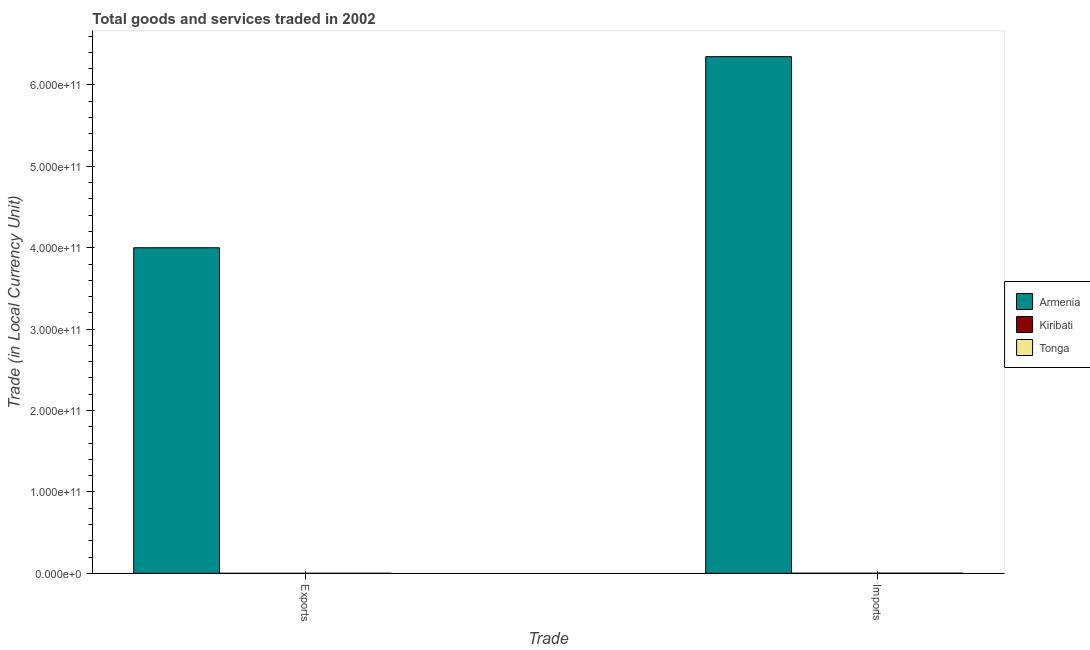How many different coloured bars are there?
Keep it short and to the point. 3. Are the number of bars on each tick of the X-axis equal?
Give a very brief answer. Yes. How many bars are there on the 1st tick from the left?
Your answer should be compact. 3. What is the label of the 2nd group of bars from the left?
Your response must be concise. Imports. What is the export of goods and services in Tonga?
Your answer should be compact. 7.27e+07. Across all countries, what is the maximum export of goods and services?
Offer a very short reply. 4.00e+11. Across all countries, what is the minimum export of goods and services?
Provide a succinct answer. 2.48e+07. In which country was the export of goods and services maximum?
Keep it short and to the point. Armenia. In which country was the export of goods and services minimum?
Provide a short and direct response. Kiribati. What is the total export of goods and services in the graph?
Your answer should be compact. 4.00e+11. What is the difference between the imports of goods and services in Armenia and that in Tonga?
Make the answer very short. 6.35e+11. What is the difference between the export of goods and services in Armenia and the imports of goods and services in Tonga?
Your answer should be very brief. 4.00e+11. What is the average export of goods and services per country?
Give a very brief answer. 1.33e+11. What is the difference between the export of goods and services and imports of goods and services in Tonga?
Provide a succinct answer. -1.49e+08. What is the ratio of the export of goods and services in Kiribati to that in Tonga?
Offer a very short reply. 0.34. What does the 1st bar from the left in Exports represents?
Give a very brief answer. Armenia. What does the 1st bar from the right in Exports represents?
Ensure brevity in your answer.  Tonga. How many bars are there?
Offer a very short reply. 6. Are all the bars in the graph horizontal?
Your answer should be compact. No. What is the difference between two consecutive major ticks on the Y-axis?
Give a very brief answer. 1.00e+11. Are the values on the major ticks of Y-axis written in scientific E-notation?
Your answer should be compact. Yes. Where does the legend appear in the graph?
Your response must be concise. Center right. How many legend labels are there?
Your response must be concise. 3. How are the legend labels stacked?
Your response must be concise. Vertical. What is the title of the graph?
Offer a terse response. Total goods and services traded in 2002. What is the label or title of the X-axis?
Your answer should be very brief. Trade. What is the label or title of the Y-axis?
Keep it short and to the point. Trade (in Local Currency Unit). What is the Trade (in Local Currency Unit) in Armenia in Exports?
Your answer should be very brief. 4.00e+11. What is the Trade (in Local Currency Unit) of Kiribati in Exports?
Your response must be concise. 2.48e+07. What is the Trade (in Local Currency Unit) in Tonga in Exports?
Ensure brevity in your answer.  7.27e+07. What is the Trade (in Local Currency Unit) of Armenia in Imports?
Keep it short and to the point. 6.35e+11. What is the Trade (in Local Currency Unit) of Kiribati in Imports?
Offer a very short reply. 1.51e+08. What is the Trade (in Local Currency Unit) of Tonga in Imports?
Provide a succinct answer. 2.21e+08. Across all Trade, what is the maximum Trade (in Local Currency Unit) of Armenia?
Offer a terse response. 6.35e+11. Across all Trade, what is the maximum Trade (in Local Currency Unit) in Kiribati?
Offer a terse response. 1.51e+08. Across all Trade, what is the maximum Trade (in Local Currency Unit) in Tonga?
Your response must be concise. 2.21e+08. Across all Trade, what is the minimum Trade (in Local Currency Unit) of Armenia?
Provide a succinct answer. 4.00e+11. Across all Trade, what is the minimum Trade (in Local Currency Unit) in Kiribati?
Make the answer very short. 2.48e+07. Across all Trade, what is the minimum Trade (in Local Currency Unit) in Tonga?
Provide a short and direct response. 7.27e+07. What is the total Trade (in Local Currency Unit) in Armenia in the graph?
Offer a very short reply. 1.03e+12. What is the total Trade (in Local Currency Unit) in Kiribati in the graph?
Offer a terse response. 1.76e+08. What is the total Trade (in Local Currency Unit) in Tonga in the graph?
Provide a succinct answer. 2.94e+08. What is the difference between the Trade (in Local Currency Unit) of Armenia in Exports and that in Imports?
Provide a succinct answer. -2.35e+11. What is the difference between the Trade (in Local Currency Unit) of Kiribati in Exports and that in Imports?
Offer a very short reply. -1.26e+08. What is the difference between the Trade (in Local Currency Unit) of Tonga in Exports and that in Imports?
Give a very brief answer. -1.49e+08. What is the difference between the Trade (in Local Currency Unit) in Armenia in Exports and the Trade (in Local Currency Unit) in Kiribati in Imports?
Your answer should be very brief. 4.00e+11. What is the difference between the Trade (in Local Currency Unit) of Armenia in Exports and the Trade (in Local Currency Unit) of Tonga in Imports?
Your response must be concise. 4.00e+11. What is the difference between the Trade (in Local Currency Unit) of Kiribati in Exports and the Trade (in Local Currency Unit) of Tonga in Imports?
Provide a succinct answer. -1.97e+08. What is the average Trade (in Local Currency Unit) in Armenia per Trade?
Your response must be concise. 5.17e+11. What is the average Trade (in Local Currency Unit) in Kiribati per Trade?
Your answer should be compact. 8.79e+07. What is the average Trade (in Local Currency Unit) in Tonga per Trade?
Make the answer very short. 1.47e+08. What is the difference between the Trade (in Local Currency Unit) of Armenia and Trade (in Local Currency Unit) of Kiribati in Exports?
Keep it short and to the point. 4.00e+11. What is the difference between the Trade (in Local Currency Unit) in Armenia and Trade (in Local Currency Unit) in Tonga in Exports?
Ensure brevity in your answer.  4.00e+11. What is the difference between the Trade (in Local Currency Unit) in Kiribati and Trade (in Local Currency Unit) in Tonga in Exports?
Offer a terse response. -4.79e+07. What is the difference between the Trade (in Local Currency Unit) in Armenia and Trade (in Local Currency Unit) in Kiribati in Imports?
Keep it short and to the point. 6.35e+11. What is the difference between the Trade (in Local Currency Unit) of Armenia and Trade (in Local Currency Unit) of Tonga in Imports?
Offer a very short reply. 6.35e+11. What is the difference between the Trade (in Local Currency Unit) of Kiribati and Trade (in Local Currency Unit) of Tonga in Imports?
Provide a succinct answer. -7.04e+07. What is the ratio of the Trade (in Local Currency Unit) in Armenia in Exports to that in Imports?
Offer a terse response. 0.63. What is the ratio of the Trade (in Local Currency Unit) of Kiribati in Exports to that in Imports?
Make the answer very short. 0.16. What is the ratio of the Trade (in Local Currency Unit) in Tonga in Exports to that in Imports?
Your answer should be very brief. 0.33. What is the difference between the highest and the second highest Trade (in Local Currency Unit) in Armenia?
Provide a succinct answer. 2.35e+11. What is the difference between the highest and the second highest Trade (in Local Currency Unit) of Kiribati?
Offer a terse response. 1.26e+08. What is the difference between the highest and the second highest Trade (in Local Currency Unit) of Tonga?
Your response must be concise. 1.49e+08. What is the difference between the highest and the lowest Trade (in Local Currency Unit) in Armenia?
Make the answer very short. 2.35e+11. What is the difference between the highest and the lowest Trade (in Local Currency Unit) of Kiribati?
Ensure brevity in your answer.  1.26e+08. What is the difference between the highest and the lowest Trade (in Local Currency Unit) of Tonga?
Give a very brief answer. 1.49e+08. 